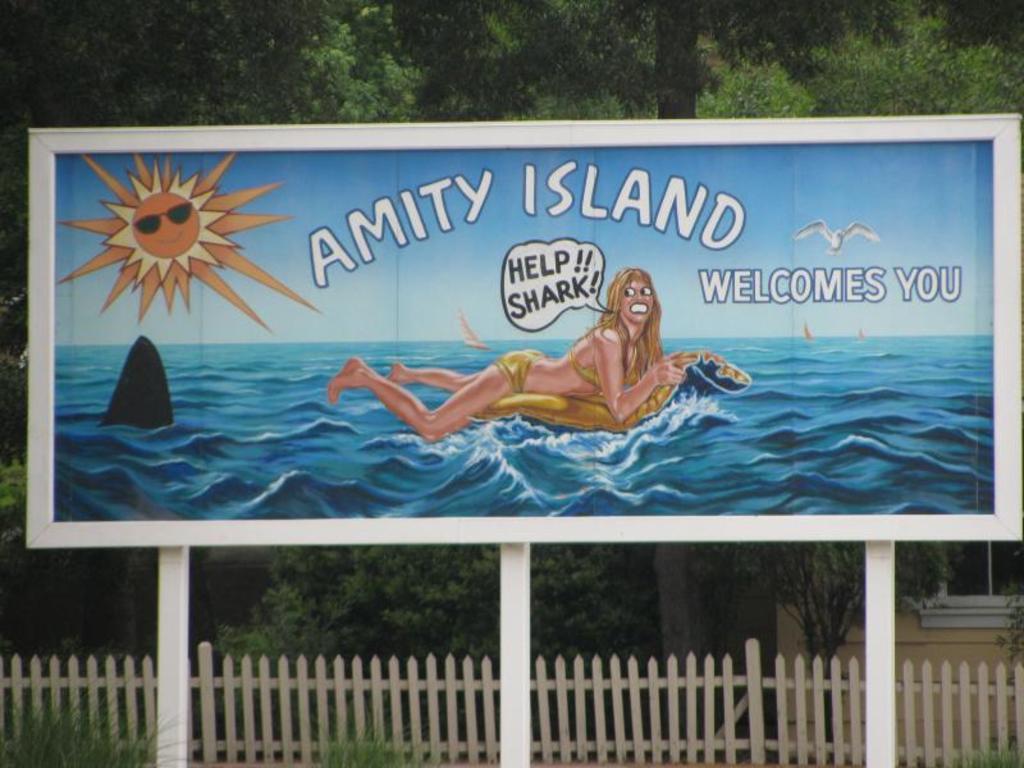In one or two sentences, can you explain what this image depicts? In this image there is a board on it there is a graphic image of a lady swimming on the sea surface, sun and few texts are there, here there is a bird. In the background there are trees. At the bottom there is a wooden fence. Here there is a building. 